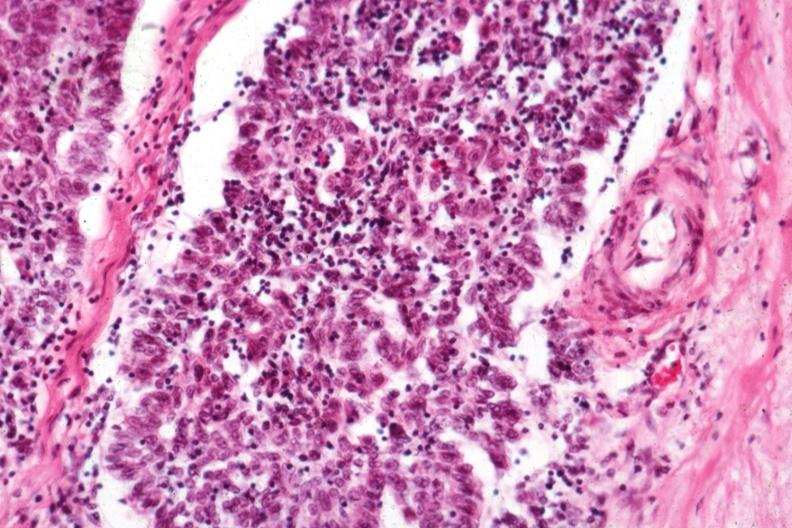what is present?
Answer the question using a single word or phrase. Thymus 